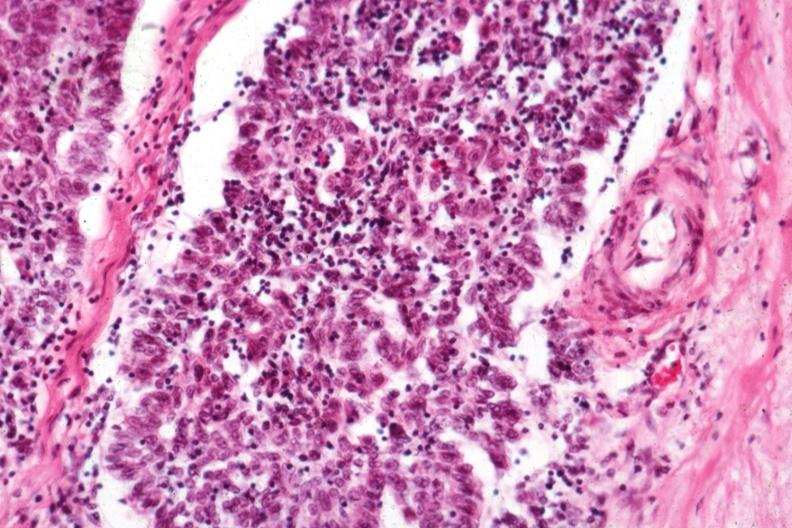what is present?
Answer the question using a single word or phrase. Thymus 